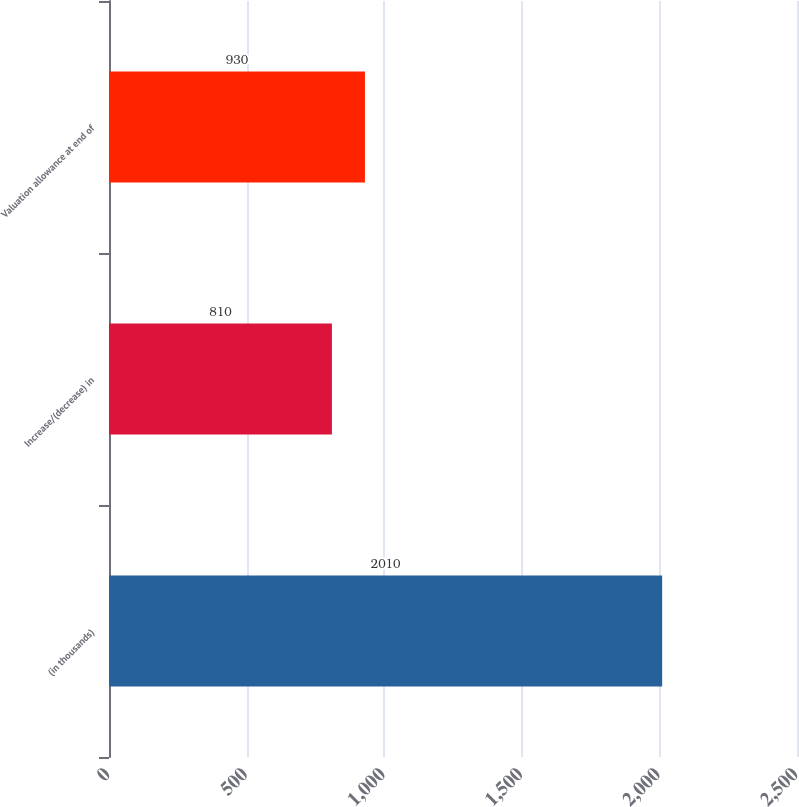Convert chart. <chart><loc_0><loc_0><loc_500><loc_500><bar_chart><fcel>(in thousands)<fcel>Increase/(decrease) in<fcel>Valuation allowance at end of<nl><fcel>2010<fcel>810<fcel>930<nl></chart> 